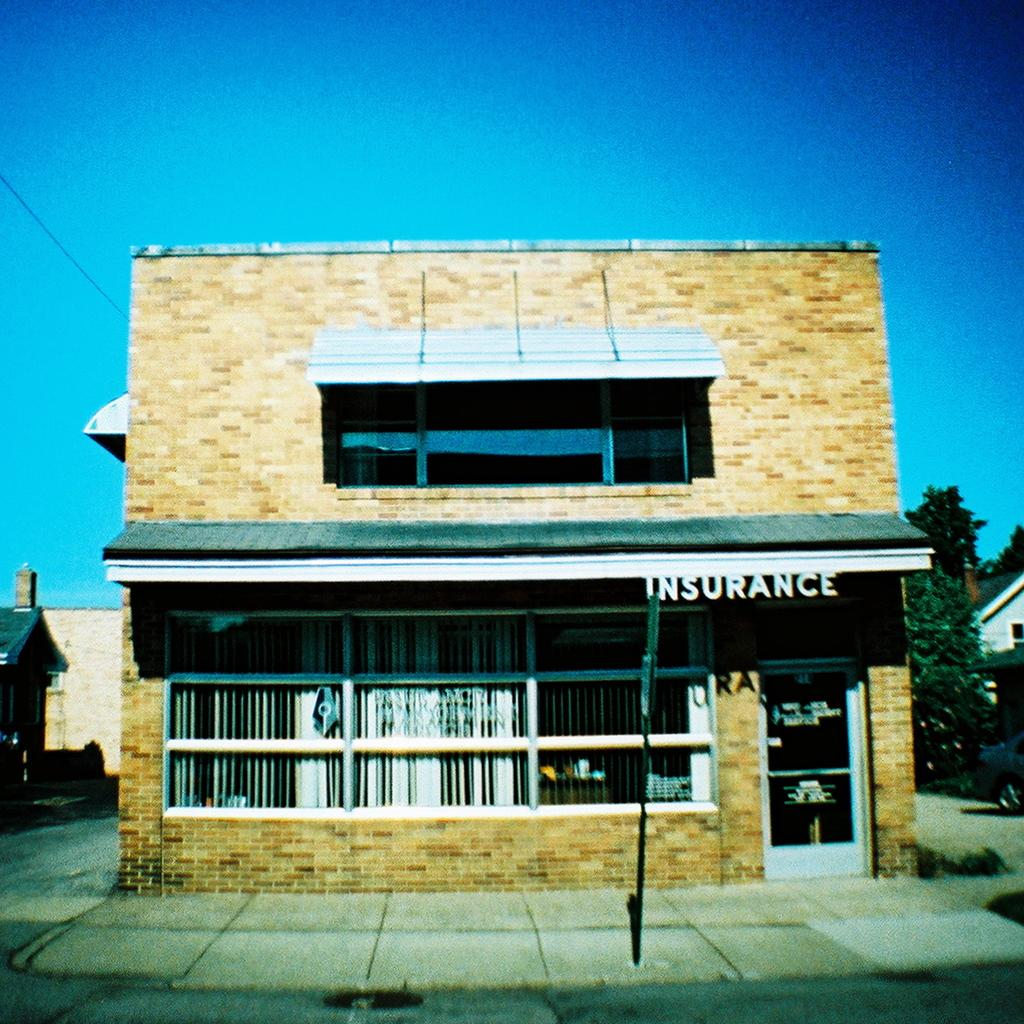What is located in the front of the image? There is a pole in the front of the image. What can be seen in the background of the image? There are buildings and trees in the background of the image. Can you describe the tent in the image? There is a tent with text written on it in front of the building. How many horses are visible in the image? There are no horses present in the image. What type of account is being advertised on the tent in the image? There is no account being advertised on the tent in the image; it only has text written on it. 